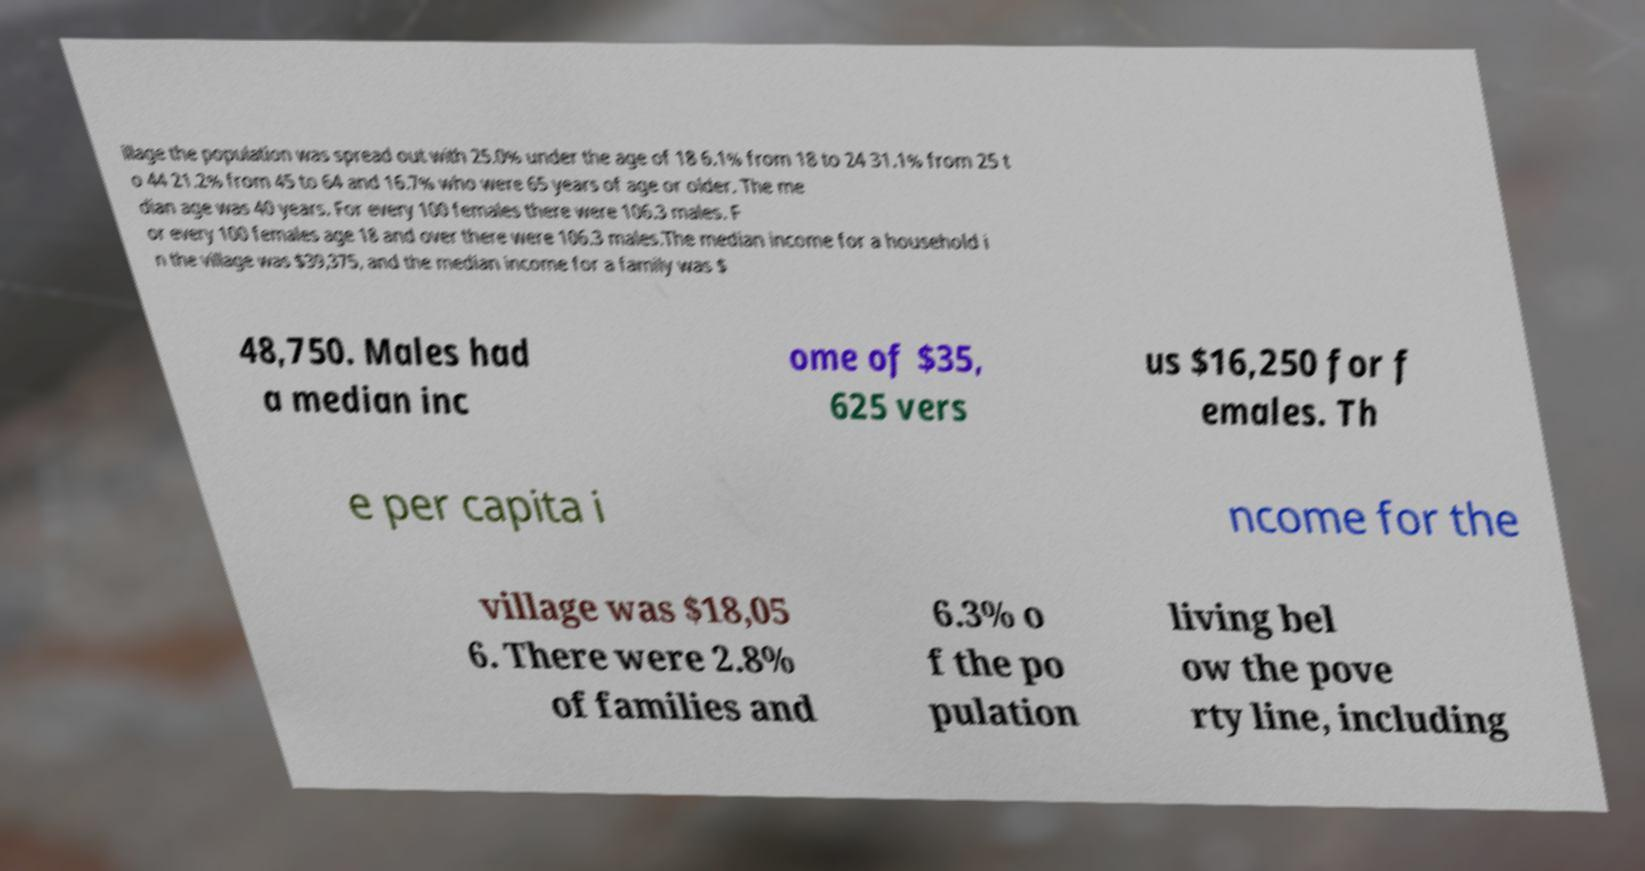What messages or text are displayed in this image? I need them in a readable, typed format. illage the population was spread out with 25.0% under the age of 18 6.1% from 18 to 24 31.1% from 25 t o 44 21.2% from 45 to 64 and 16.7% who were 65 years of age or older. The me dian age was 40 years. For every 100 females there were 106.3 males. F or every 100 females age 18 and over there were 106.3 males.The median income for a household i n the village was $39,375, and the median income for a family was $ 48,750. Males had a median inc ome of $35, 625 vers us $16,250 for f emales. Th e per capita i ncome for the village was $18,05 6. There were 2.8% of families and 6.3% o f the po pulation living bel ow the pove rty line, including 